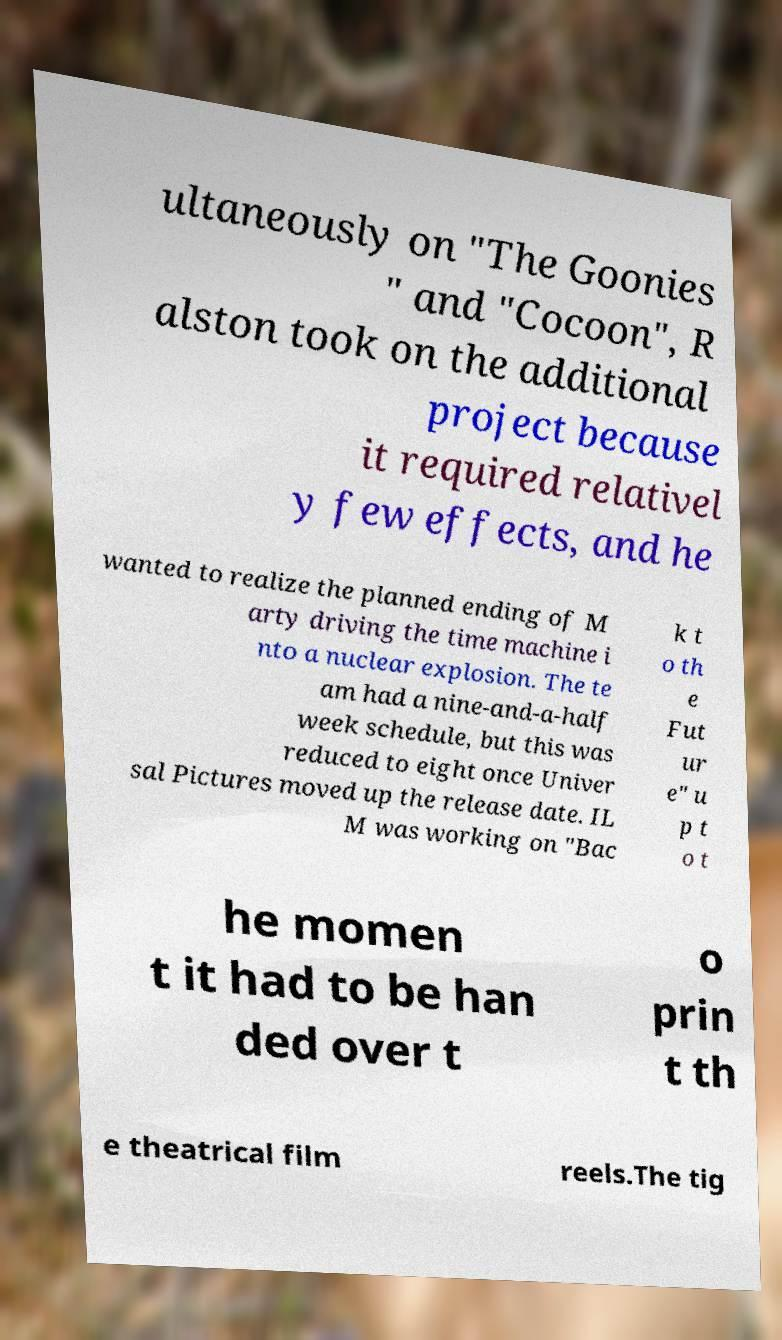What messages or text are displayed in this image? I need them in a readable, typed format. ultaneously on "The Goonies " and "Cocoon", R alston took on the additional project because it required relativel y few effects, and he wanted to realize the planned ending of M arty driving the time machine i nto a nuclear explosion. The te am had a nine-and-a-half week schedule, but this was reduced to eight once Univer sal Pictures moved up the release date. IL M was working on "Bac k t o th e Fut ur e" u p t o t he momen t it had to be han ded over t o prin t th e theatrical film reels.The tig 